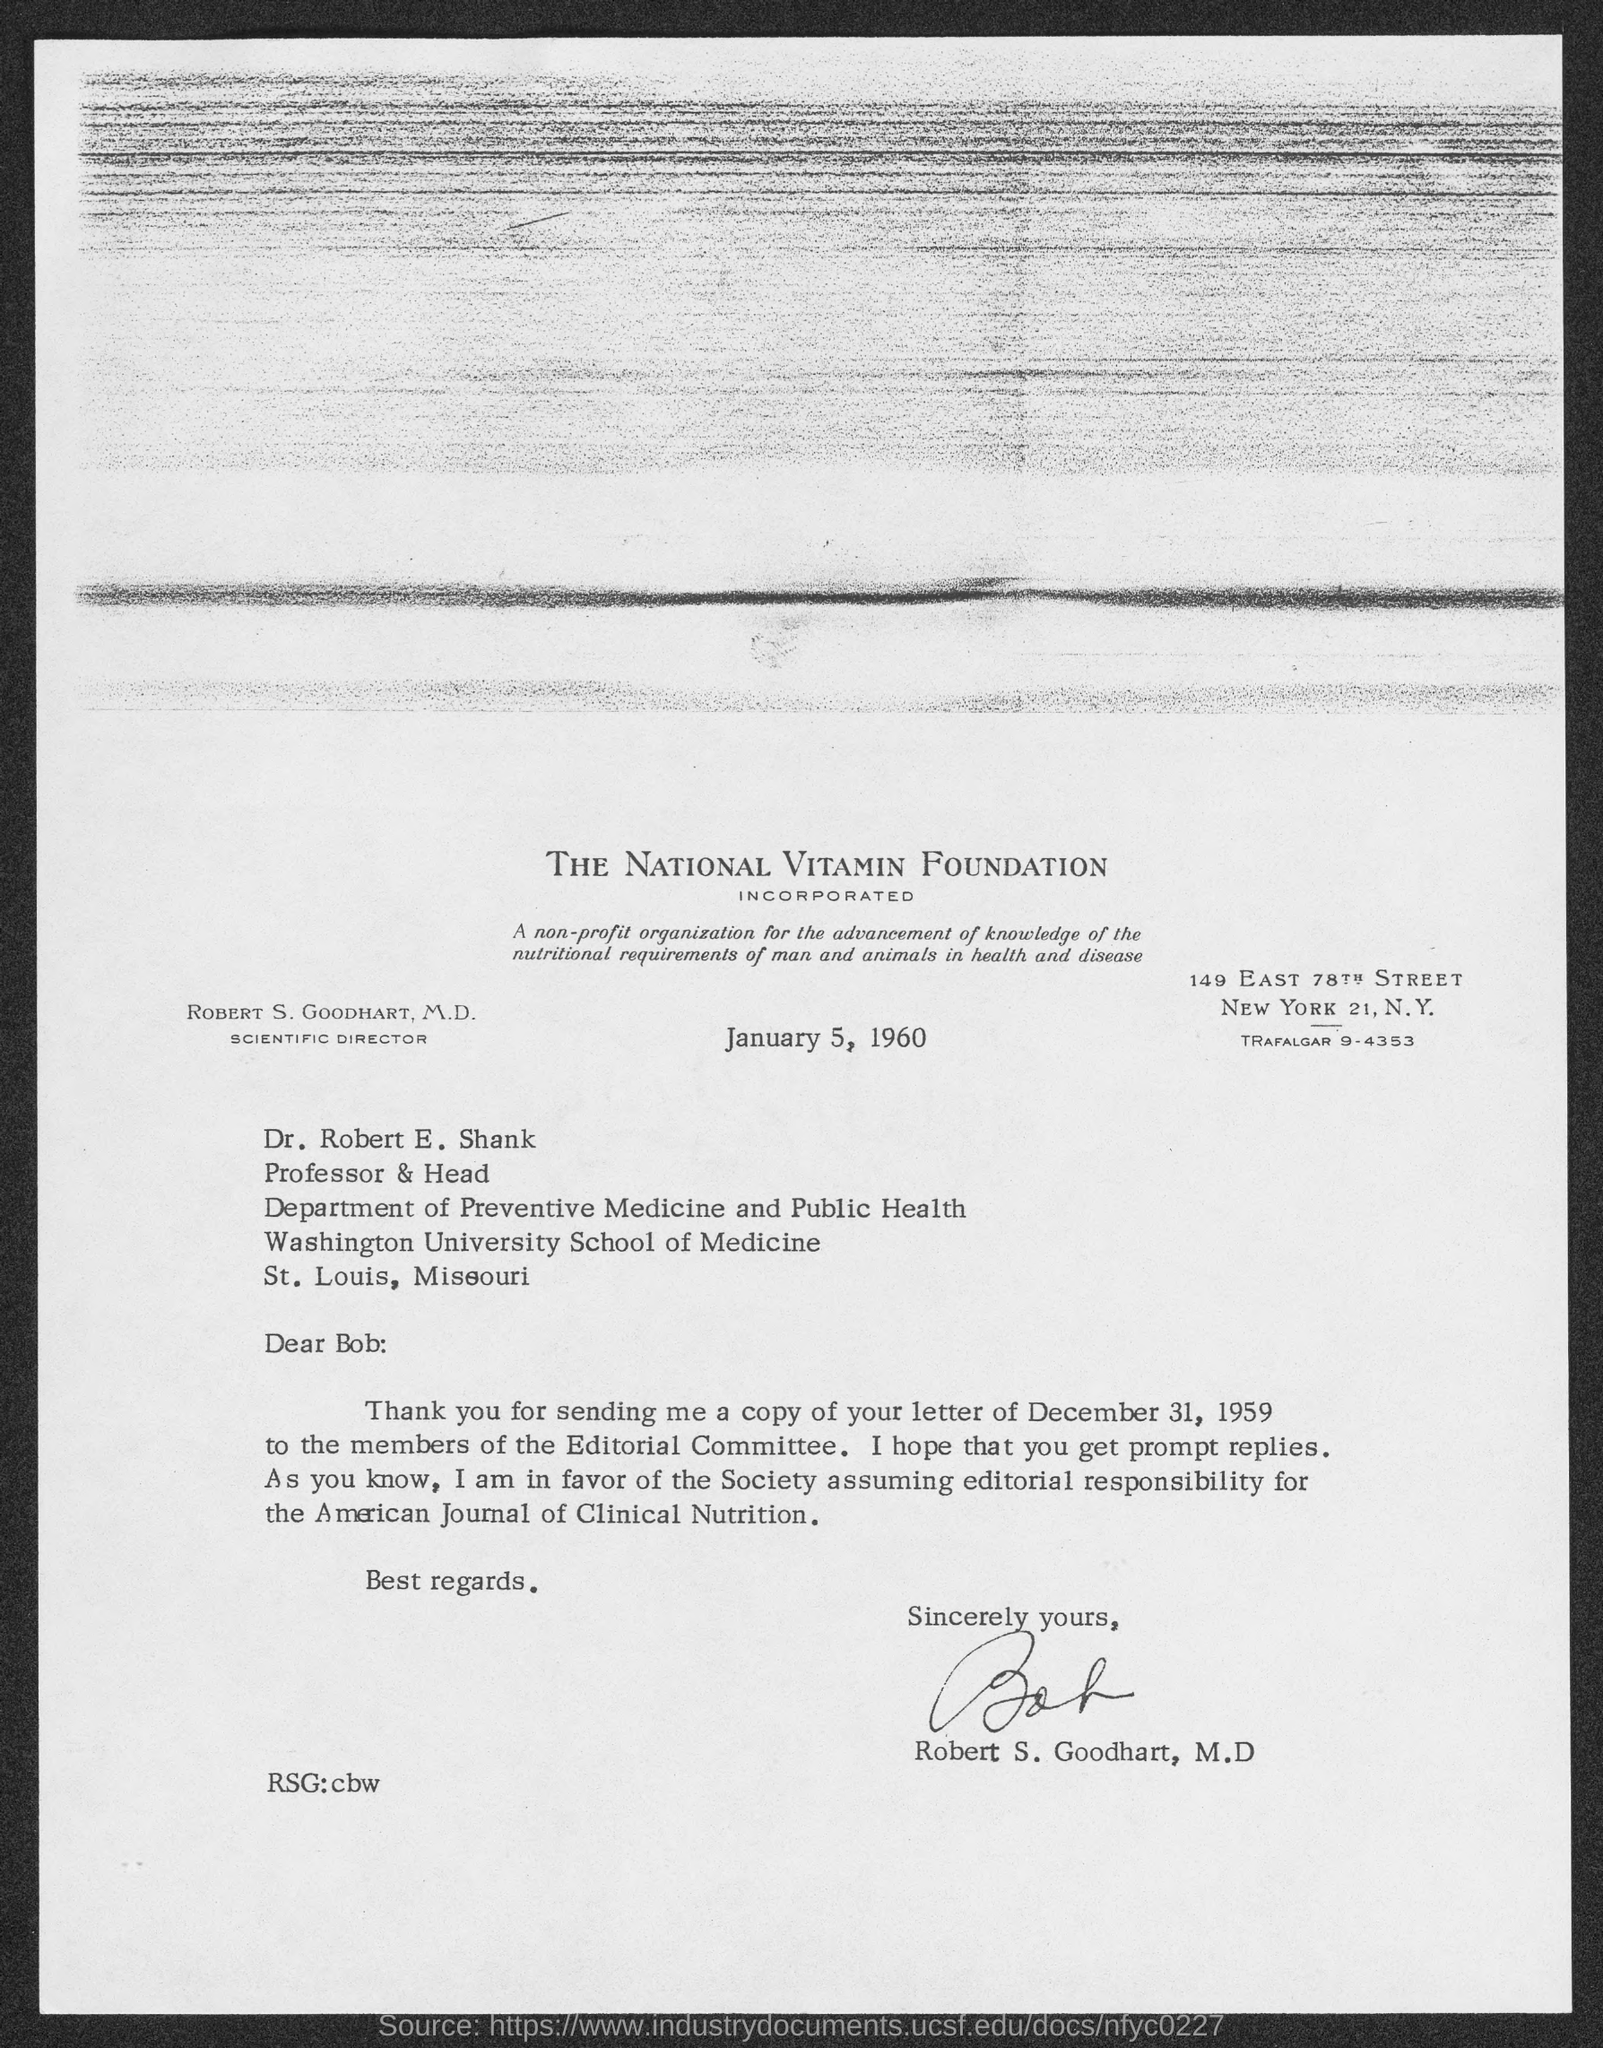Point out several critical features in this image. The letter is from Robert S. Goodhart, M.D. The date on the document is January 5, 1960. 